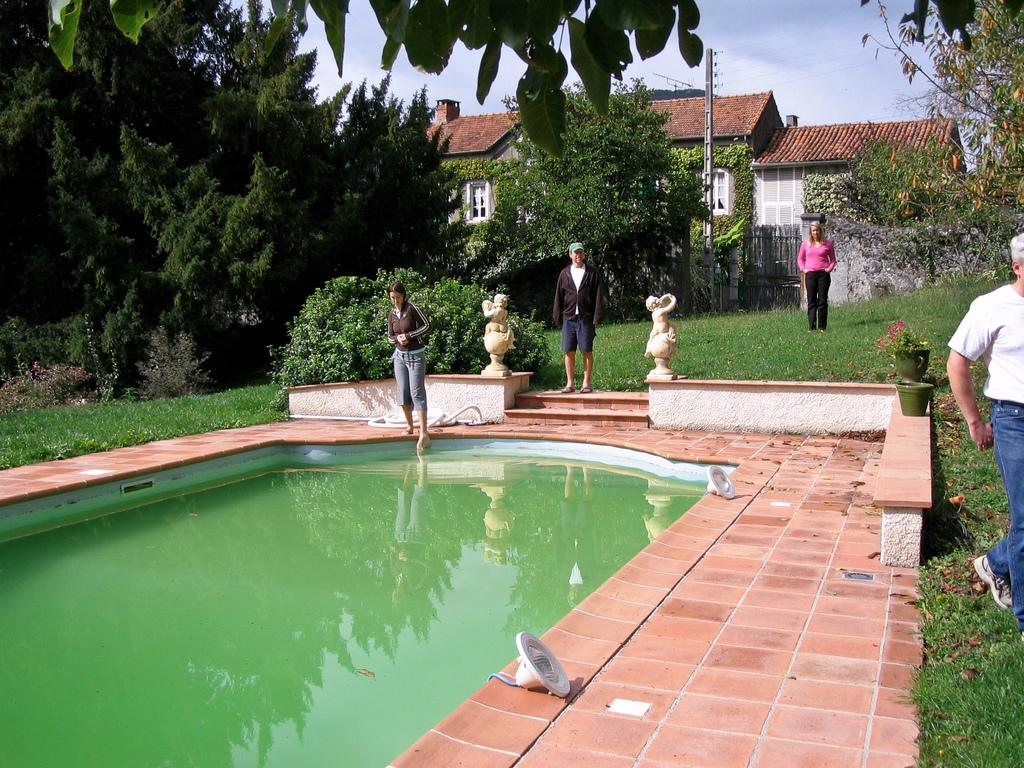What is the primary element visible in the image? There is water in the image. How many people are present in the image? There are four persons in the image. What type of vegetation can be seen in the image? There are plants and trees in the image. What type of structures are visible in the image? There are houses in the image. What is the purpose of the pole in the image? The purpose of the pole is not specified in the image, but it could be for support or signage. What type of ground surface is visible in the image? There is grass in the image. What is visible in the background of the image? The sky is visible in the background of the image. What type of soda is being advertised on the design of the acoustics in the image? There is no soda or advertisement present in the image, nor is there any mention of acoustics. 